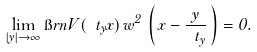Convert formula to latex. <formula><loc_0><loc_0><loc_500><loc_500>\lim _ { | y | \to \infty } \i r n V ( \ t _ { y } x ) \, w ^ { 2 } \, \left ( \, x - \frac { y } { \ t _ { y } } \, \right ) = 0 .</formula> 